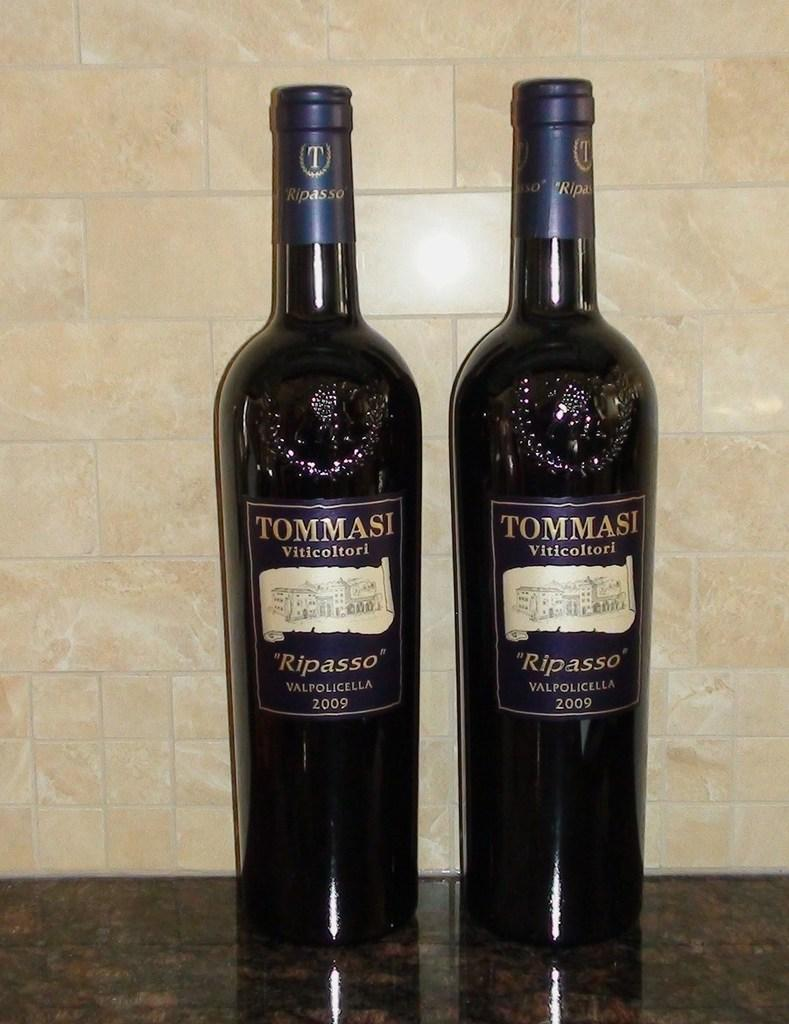<image>
Write a terse but informative summary of the picture. Tommasi brand wine sits on a shiny kitchen counter. 